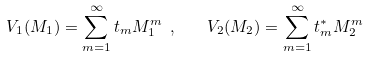Convert formula to latex. <formula><loc_0><loc_0><loc_500><loc_500>V _ { 1 } ( M _ { 1 } ) = \sum _ { m = 1 } ^ { \infty } t _ { m } M _ { 1 } ^ { m } \ , \quad V _ { 2 } ( M _ { 2 } ) = \sum _ { m = 1 } ^ { \infty } t _ { m } ^ { * } M _ { 2 } ^ { m }</formula> 